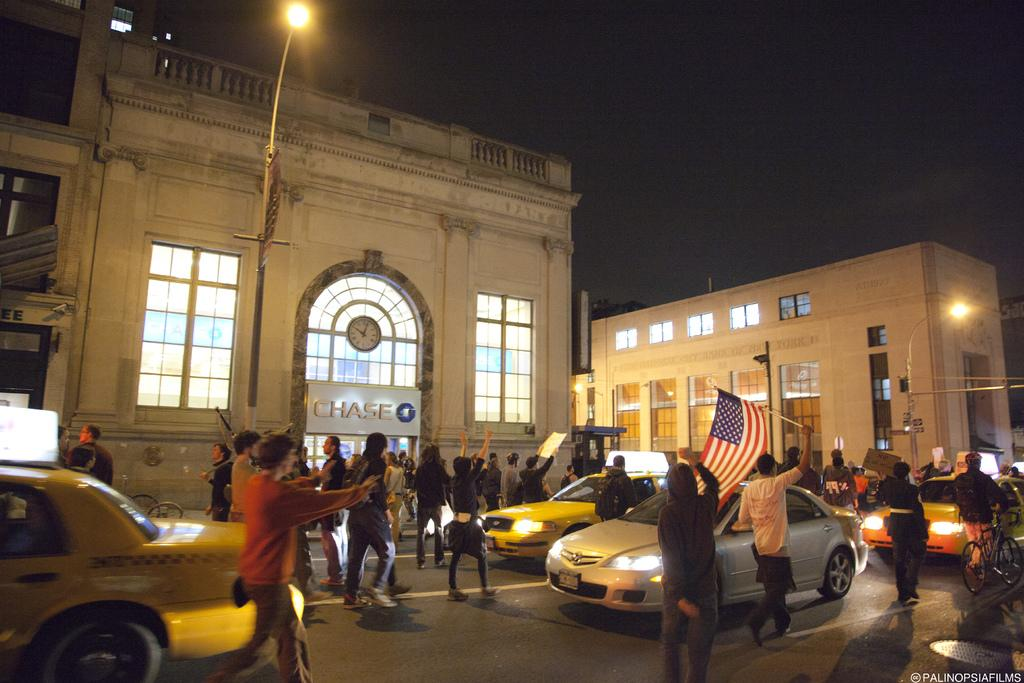<image>
Provide a brief description of the given image. A street is teeming with people celebrating and they pass a building with CHASE above the entrance. 